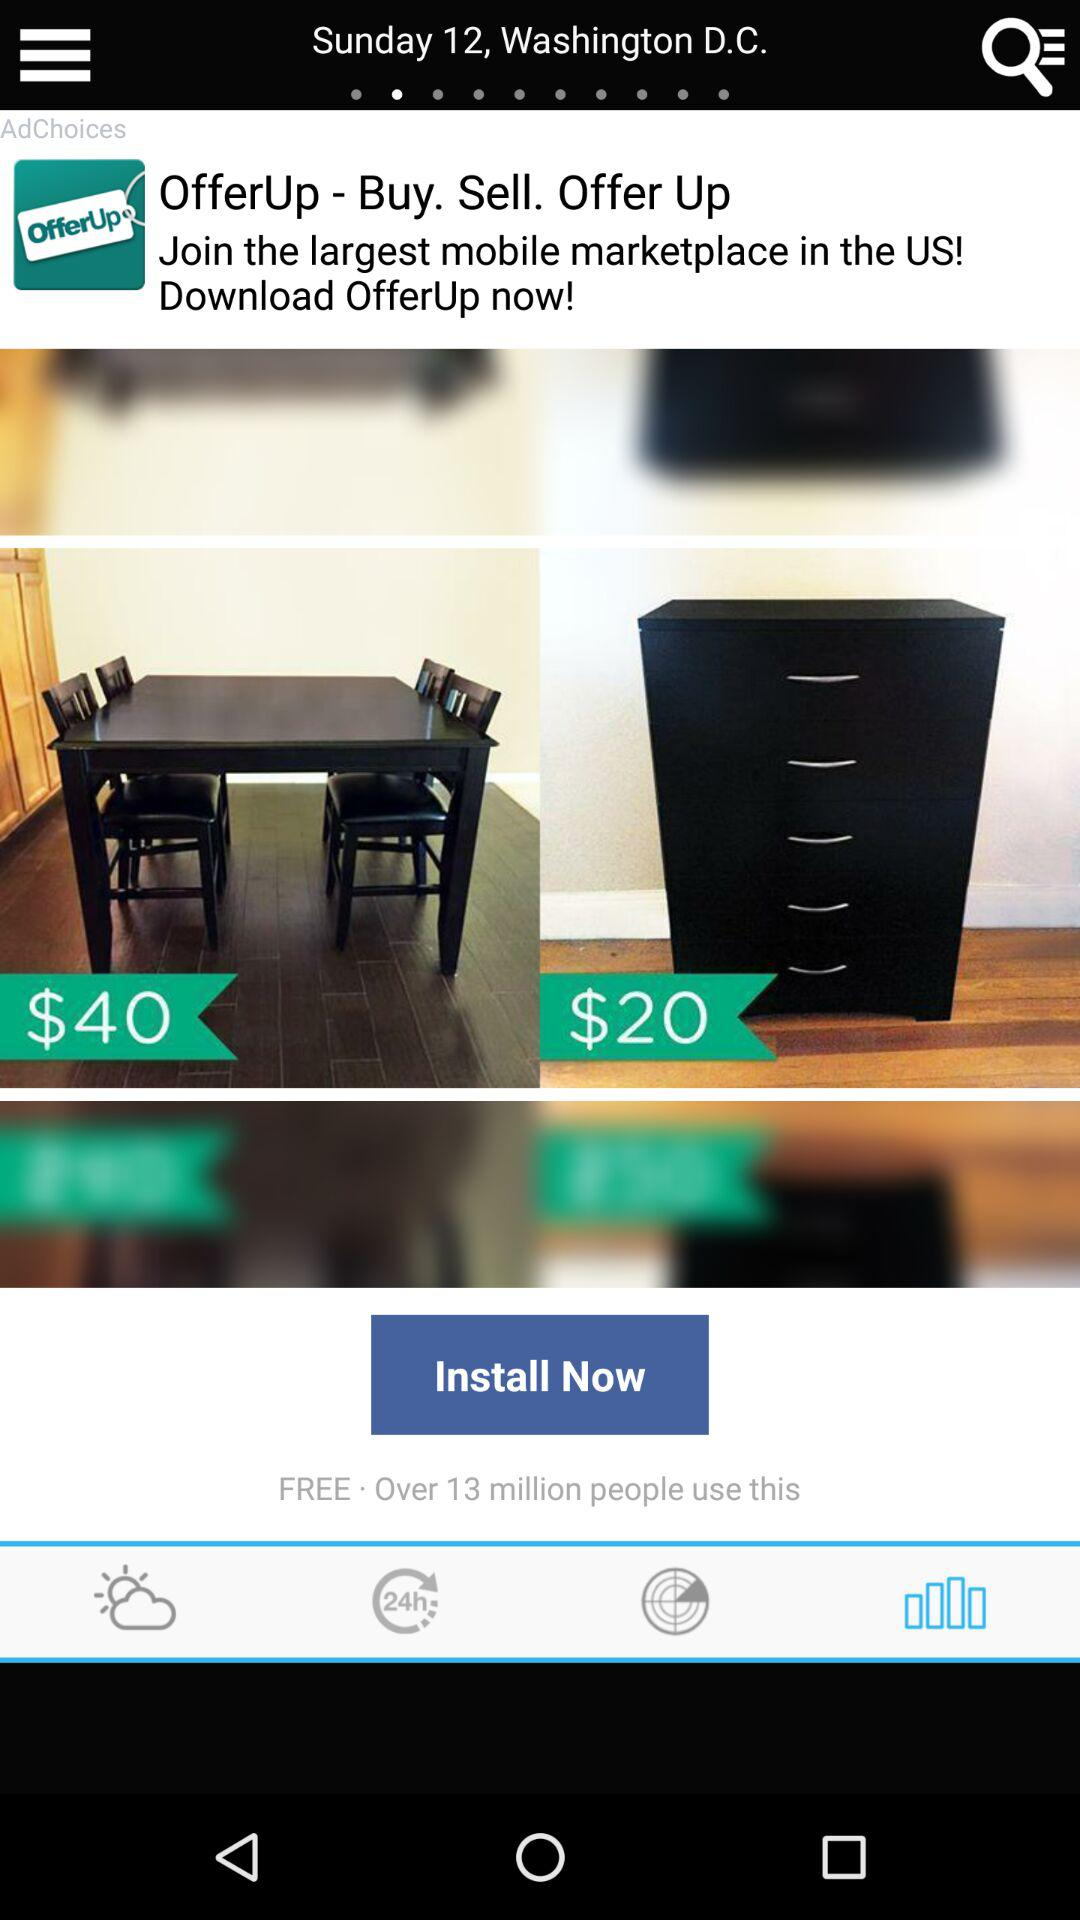How many users use "OfferUp"? "OfferUp" is used by over 13 million users. 